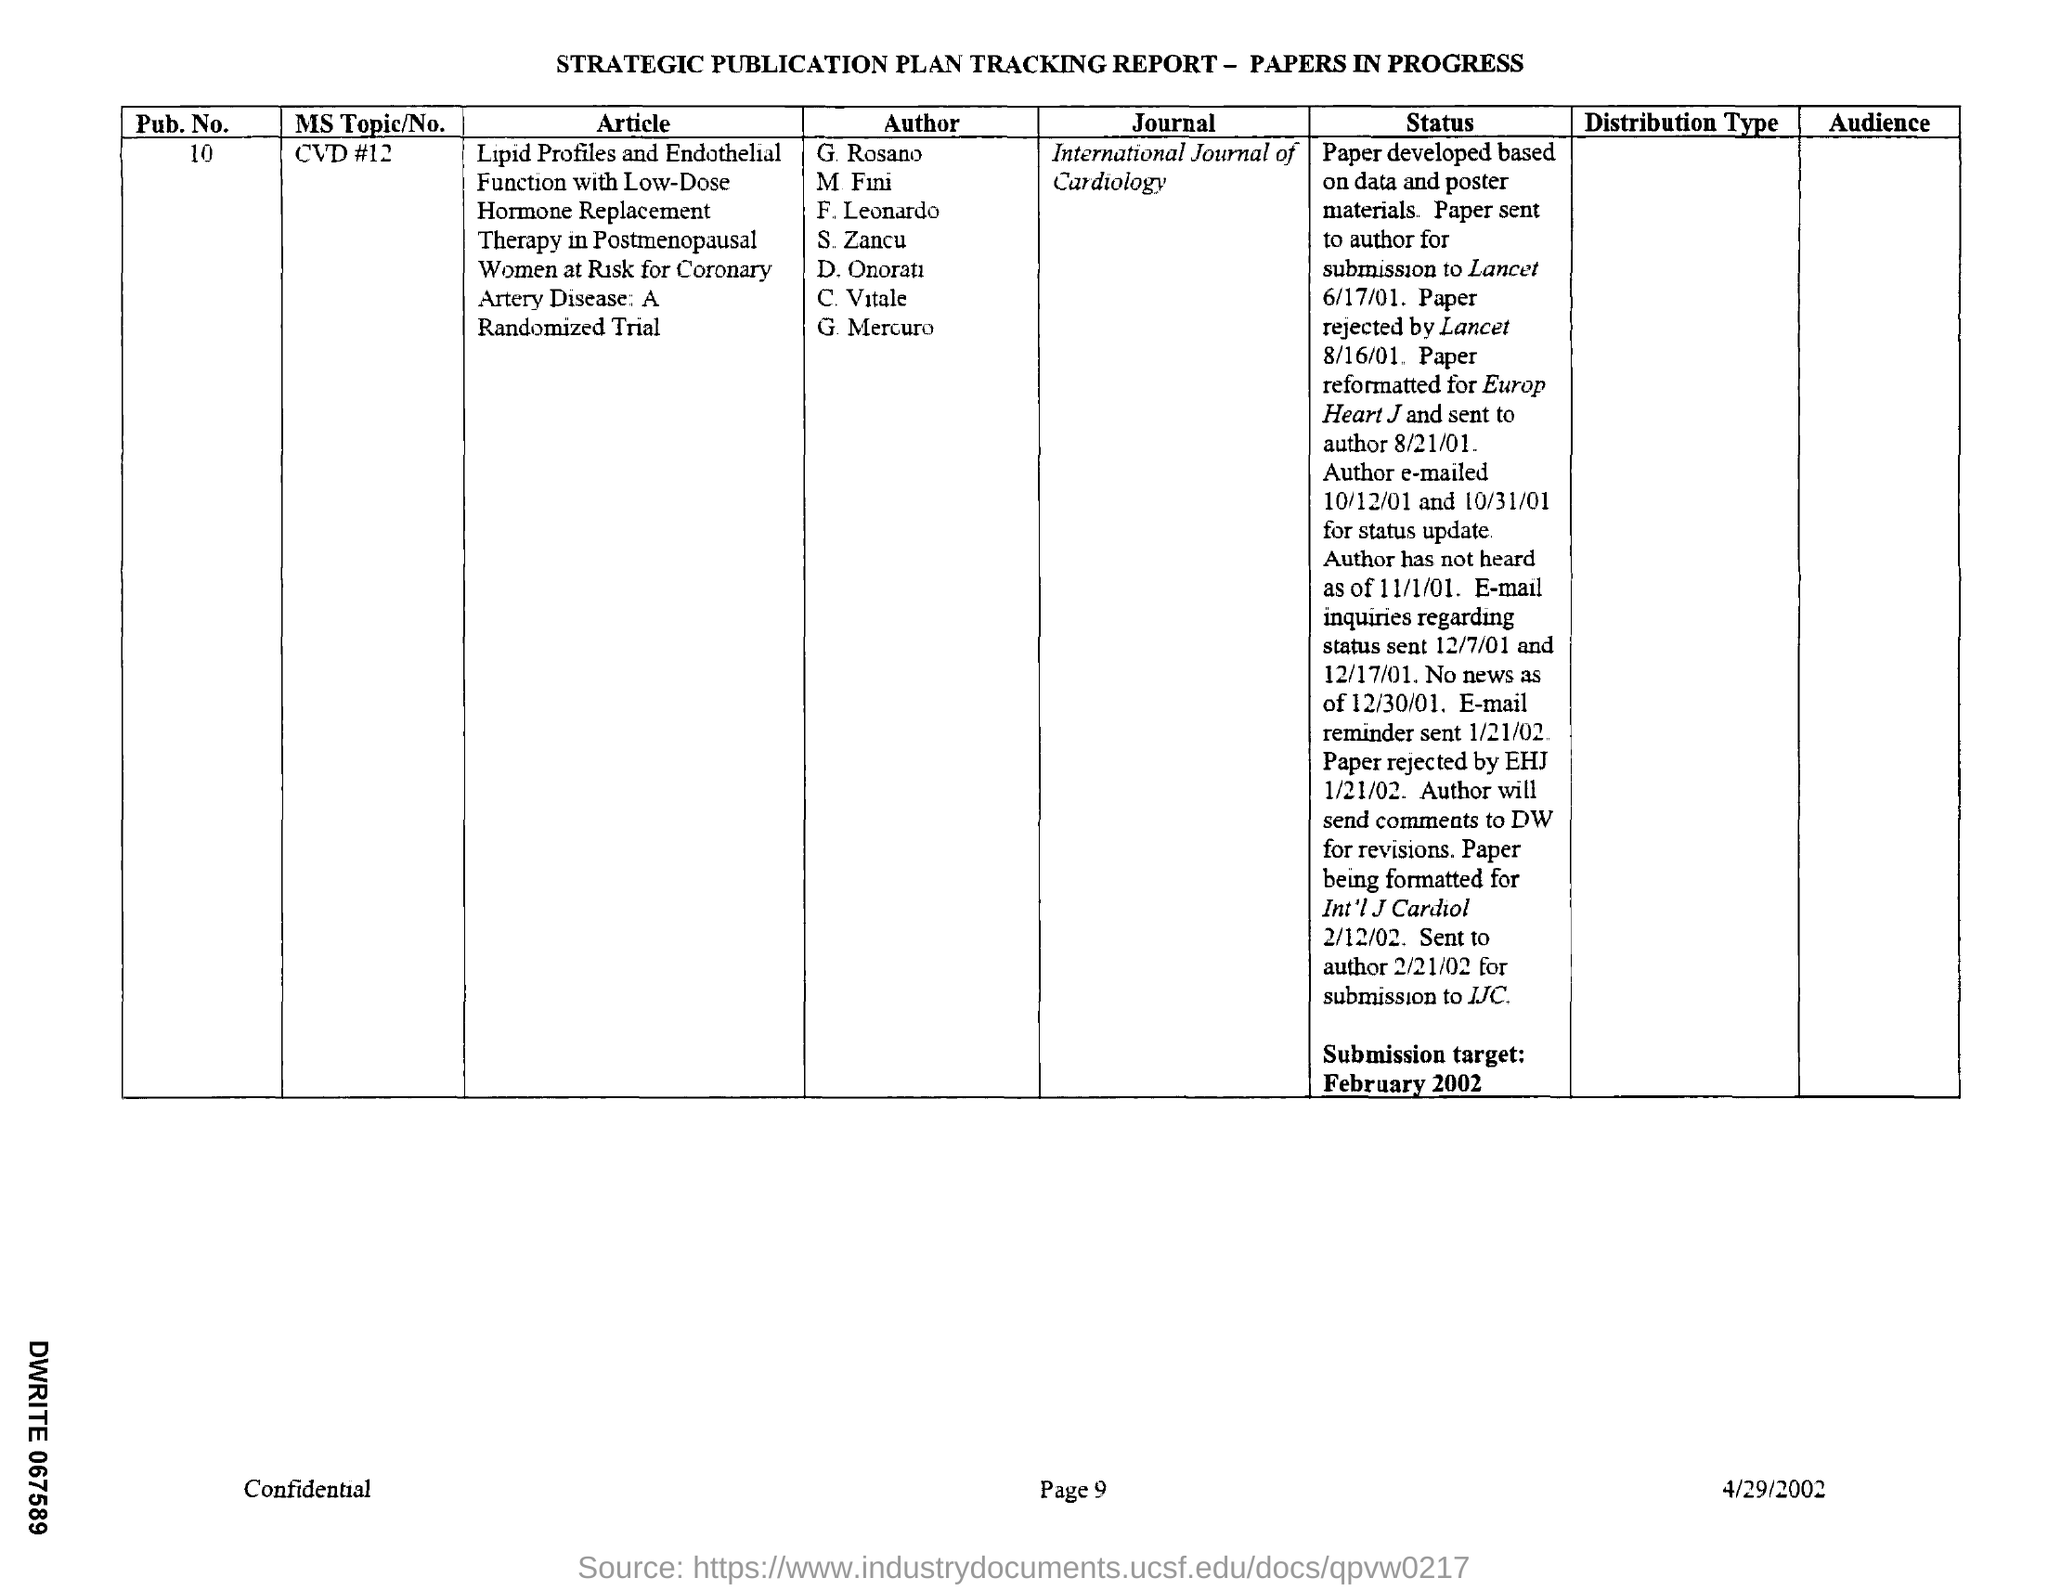What is the pub .no. mentioned in the given tracking report ?
Give a very brief answer. 10. 